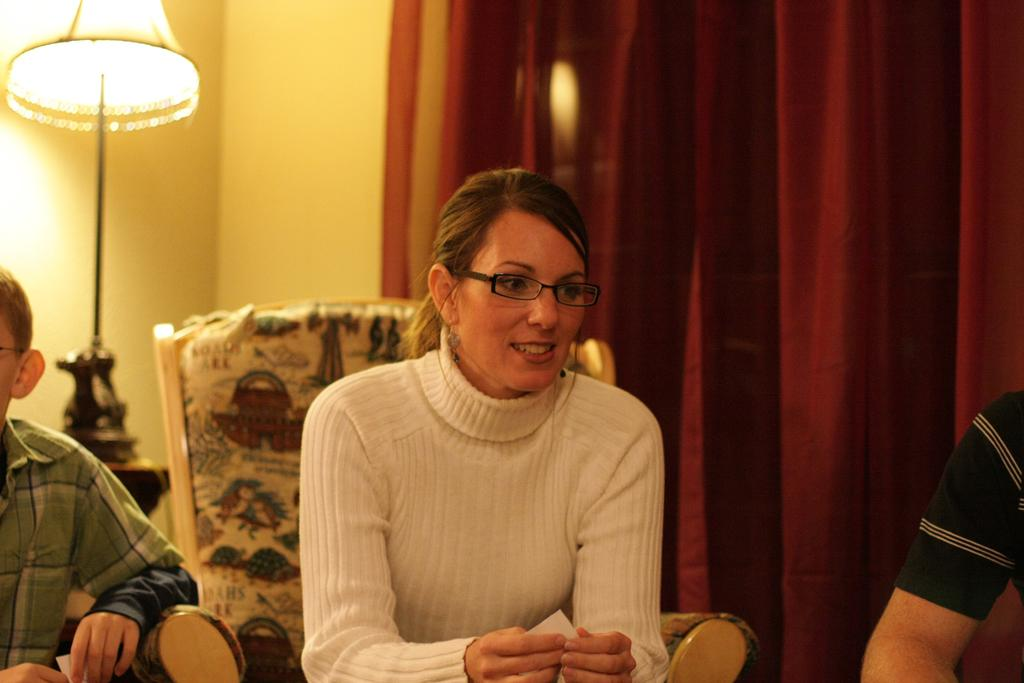What color is the wall that is visible in the image? There is a yellow color wall in the image. What type of window treatment can be seen in the image? There are curtains in the image. What type of lighting is present in the image? There is a lamp in the image. How many people are sitting on the sofa in the image? There are three people sitting on a sofa in the image. What is the creator's belief about the wall in the image? There is no information about the creator's belief in the image, as it only shows a yellow wall, curtains, a lamp, and three people sitting on a sofa. How much water is present in the image? There is no water visible in the image. 